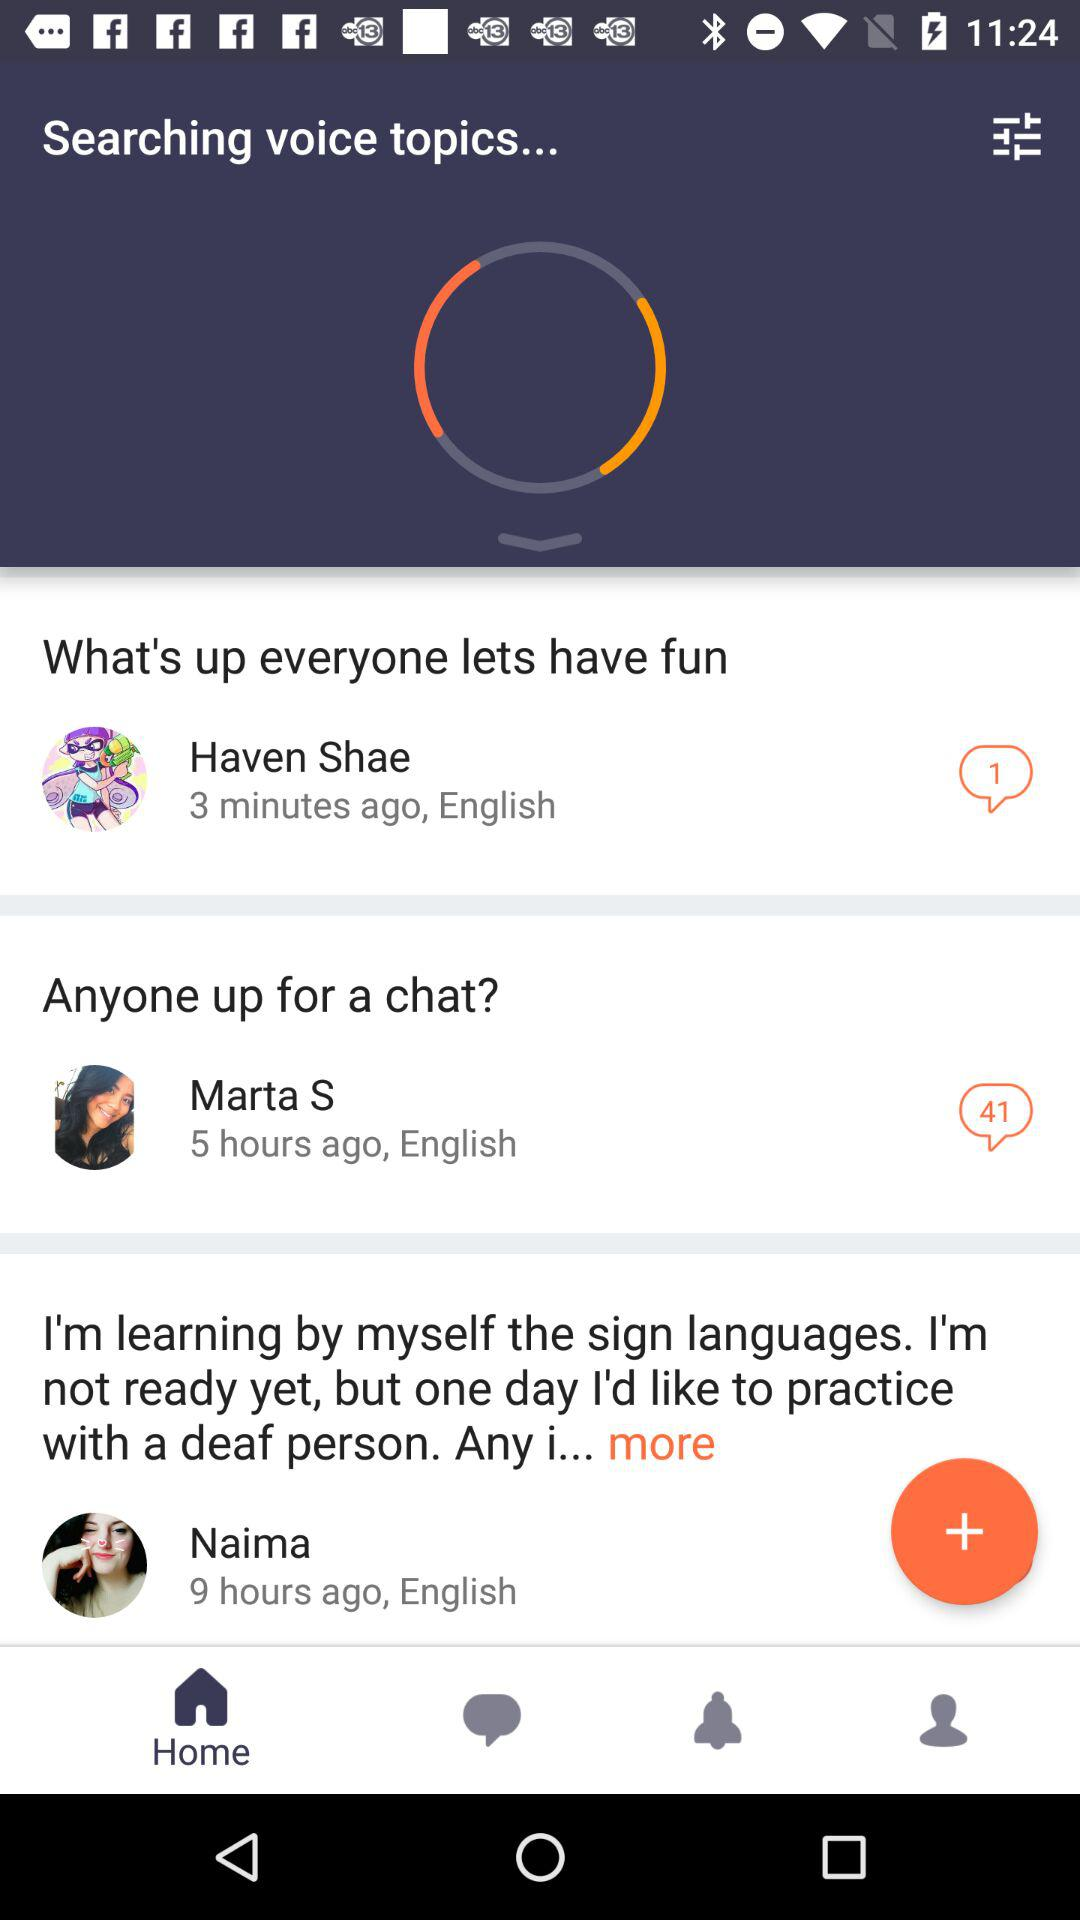When did Haven Shae comment? Haven Shae commented 3 minutes ago. 